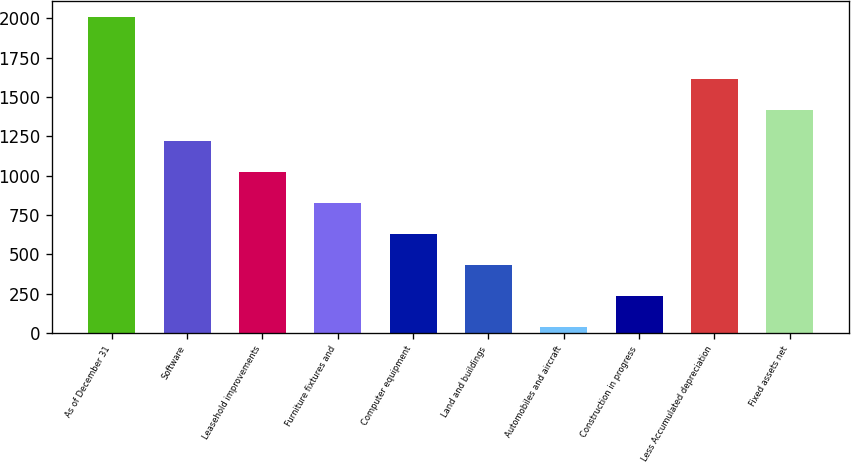Convert chart to OTSL. <chart><loc_0><loc_0><loc_500><loc_500><bar_chart><fcel>As of December 31<fcel>Software<fcel>Leasehold improvements<fcel>Furniture fixtures and<fcel>Computer equipment<fcel>Land and buildings<fcel>Automobiles and aircraft<fcel>Construction in progress<fcel>Less Accumulated depreciation<fcel>Fixed assets net<nl><fcel>2010<fcel>1221.6<fcel>1024.5<fcel>827.4<fcel>630.3<fcel>433.2<fcel>39<fcel>236.1<fcel>1615.8<fcel>1418.7<nl></chart> 